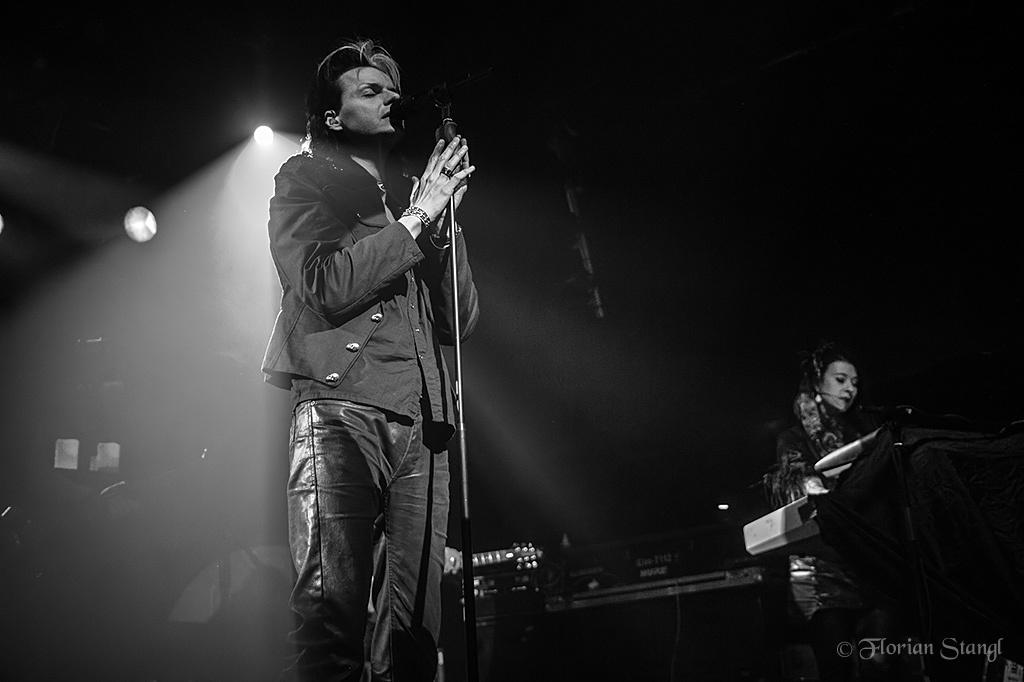How many people are in the image? There are two persons standing in the image. What is one person doing with their hands? One person is holding a microphone. What activity is the person with the microphone engaged in? The person holding the microphone is singing. What can be seen in the background of the image? There are focusing lights and musical instruments in the background. Reasoning: Let' Let's think step by step in order to produce the conversation. We start by identifying the number of people in the image, which is two. Then, we describe the actions of one of the persons, who is holding a microphone and singing. Next, we mention the presence of focusing lights and musical instruments in the background, which provide context for the scene. Absurd Question/Answer: What type of soap is being used by the person singing in the image? There is no soap present in the image, as it features two persons, one of whom is singing with a microphone. 